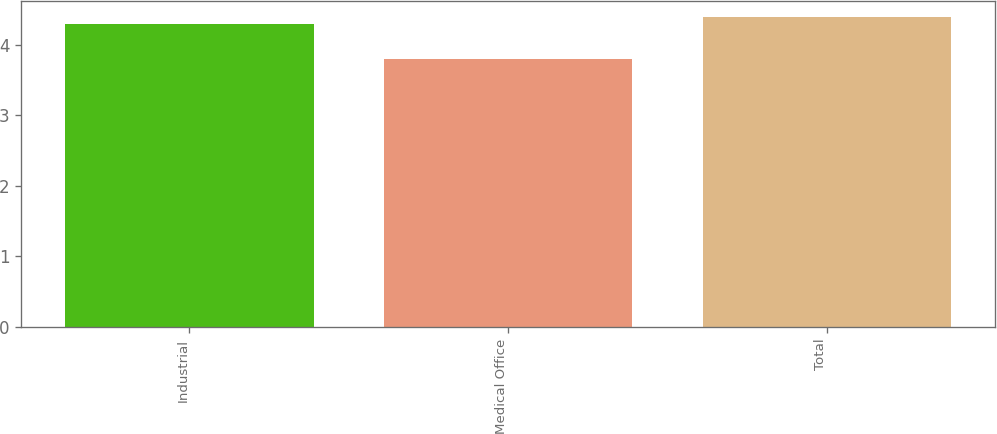<chart> <loc_0><loc_0><loc_500><loc_500><bar_chart><fcel>Industrial<fcel>Medical Office<fcel>Total<nl><fcel>4.3<fcel>3.8<fcel>4.4<nl></chart> 